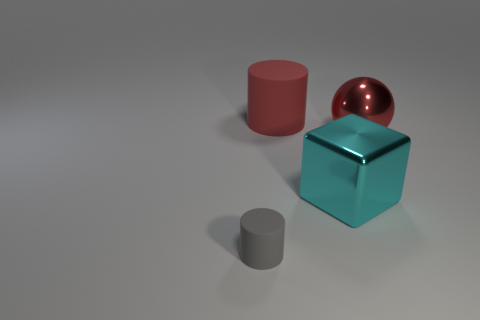What is the color of the other large rubber object that is the same shape as the gray object?
Make the answer very short. Red. What number of objects are either red objects or small cyan metallic cylinders?
Ensure brevity in your answer.  2. There is a big cyan object that is the same material as the sphere; what is its shape?
Provide a succinct answer. Cube. What number of big things are cyan rubber blocks or red objects?
Your response must be concise. 2. How many other things are there of the same color as the large shiny sphere?
Ensure brevity in your answer.  1. What number of matte cylinders are in front of the large red object that is to the right of the matte cylinder that is right of the small gray matte cylinder?
Provide a succinct answer. 1. Is the size of the matte thing that is behind the sphere the same as the cube?
Provide a short and direct response. Yes. Is the number of red cylinders that are right of the red metallic object less than the number of tiny objects that are left of the large red matte thing?
Provide a succinct answer. Yes. Do the metallic ball and the big cylinder have the same color?
Keep it short and to the point. Yes. Are there fewer tiny gray things on the right side of the large sphere than large brown shiny cubes?
Offer a very short reply. No. 